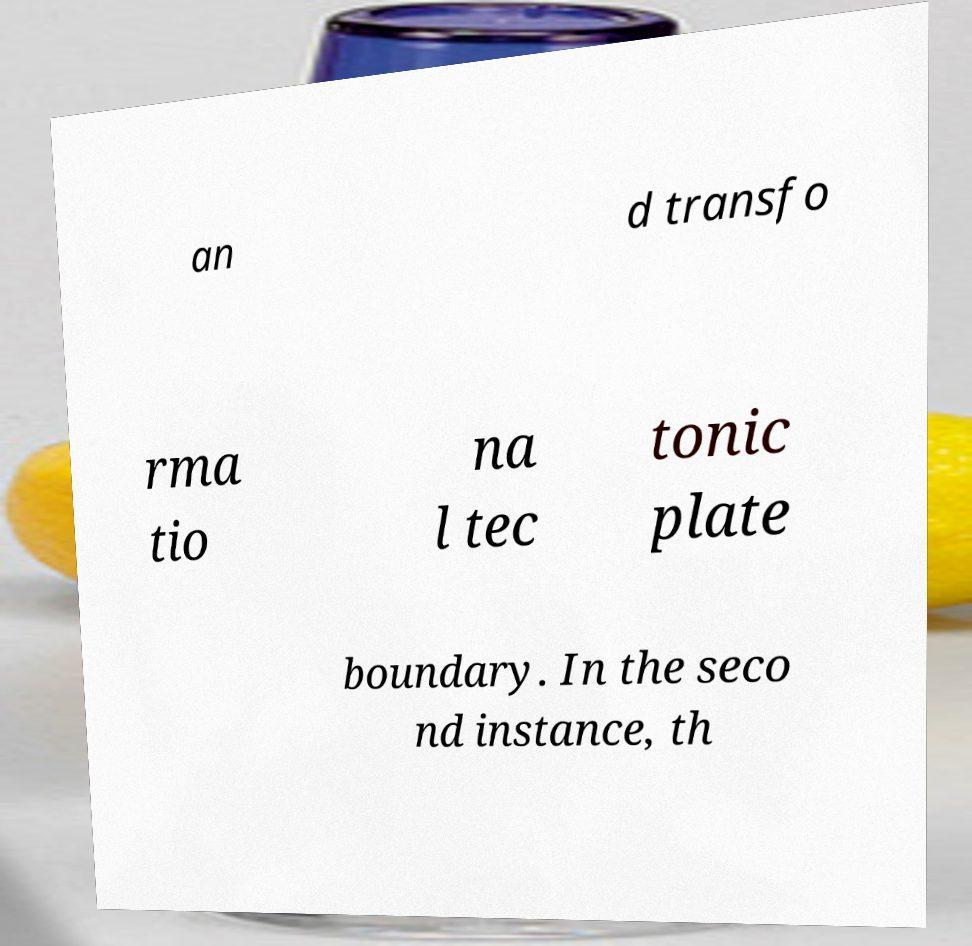Please identify and transcribe the text found in this image. an d transfo rma tio na l tec tonic plate boundary. In the seco nd instance, th 